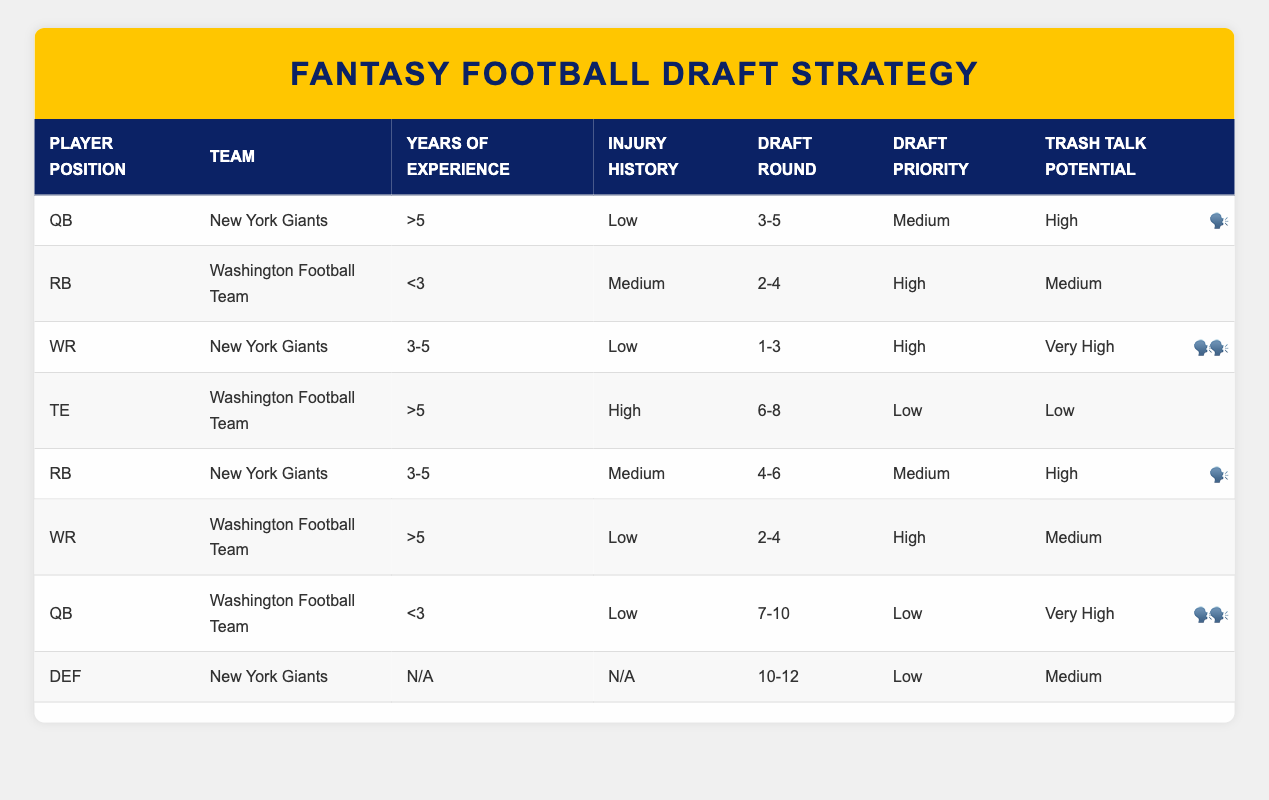What player position for the New York Giants has the highest trash talk potential? The row for the New York Giants WR indicates "Very High" for trash talk potential. Other positions either have "High" or "Medium".
Answer: WR What draft round should you expect for a Washington Football Team RB with less than 3 years of experience? The row for the Washington Football Team RB states the draft round is "2-4".
Answer: 2-4 Are there any players in the table with high injury history? The TE from the Washington Football Team has a "High" injury history, while all other entries have either "Low" or "Medium".
Answer: Yes What draft priority does a New York Giants RB with 3-5 years of experience have? The table indicates that the New York Giants RB with 3-5 years of experience has a "Medium" draft priority.
Answer: Medium Which player positions from the Washington Football Team have high trash talk potential? Only the WR from the Washington Football Team has "Medium" trash talk potential, while no positions have "High". Thus, there are no positions with high trash talk potential.
Answer: None What is the average draft round for players from the New York Giants? The draft rounds for the New York Giants players are 3-5 (for QB), 1-3 (for WR), 4-6 (for RB), and 10-12 (for DEF). To find the average: (4 + 1 + 5 + 10) / 4 = 5.
Answer: 5 Is the draft round for a QB from Washington Football Team above 5? The draft round for the Washington Football Team QB is "7-10", which is indeed above 5.
Answer: Yes Which player from the Washington Football Team has the least years of experience? The RB from the Washington Football Team has less than 3 years of experience, which is the least compared to others listed.
Answer: RB What draft priority would you assign to a TE from the Washington Football Team with more than 5 years of experience? The TE from the Washington Football Team has a "Low" draft priority due to its high injury history.
Answer: Low 